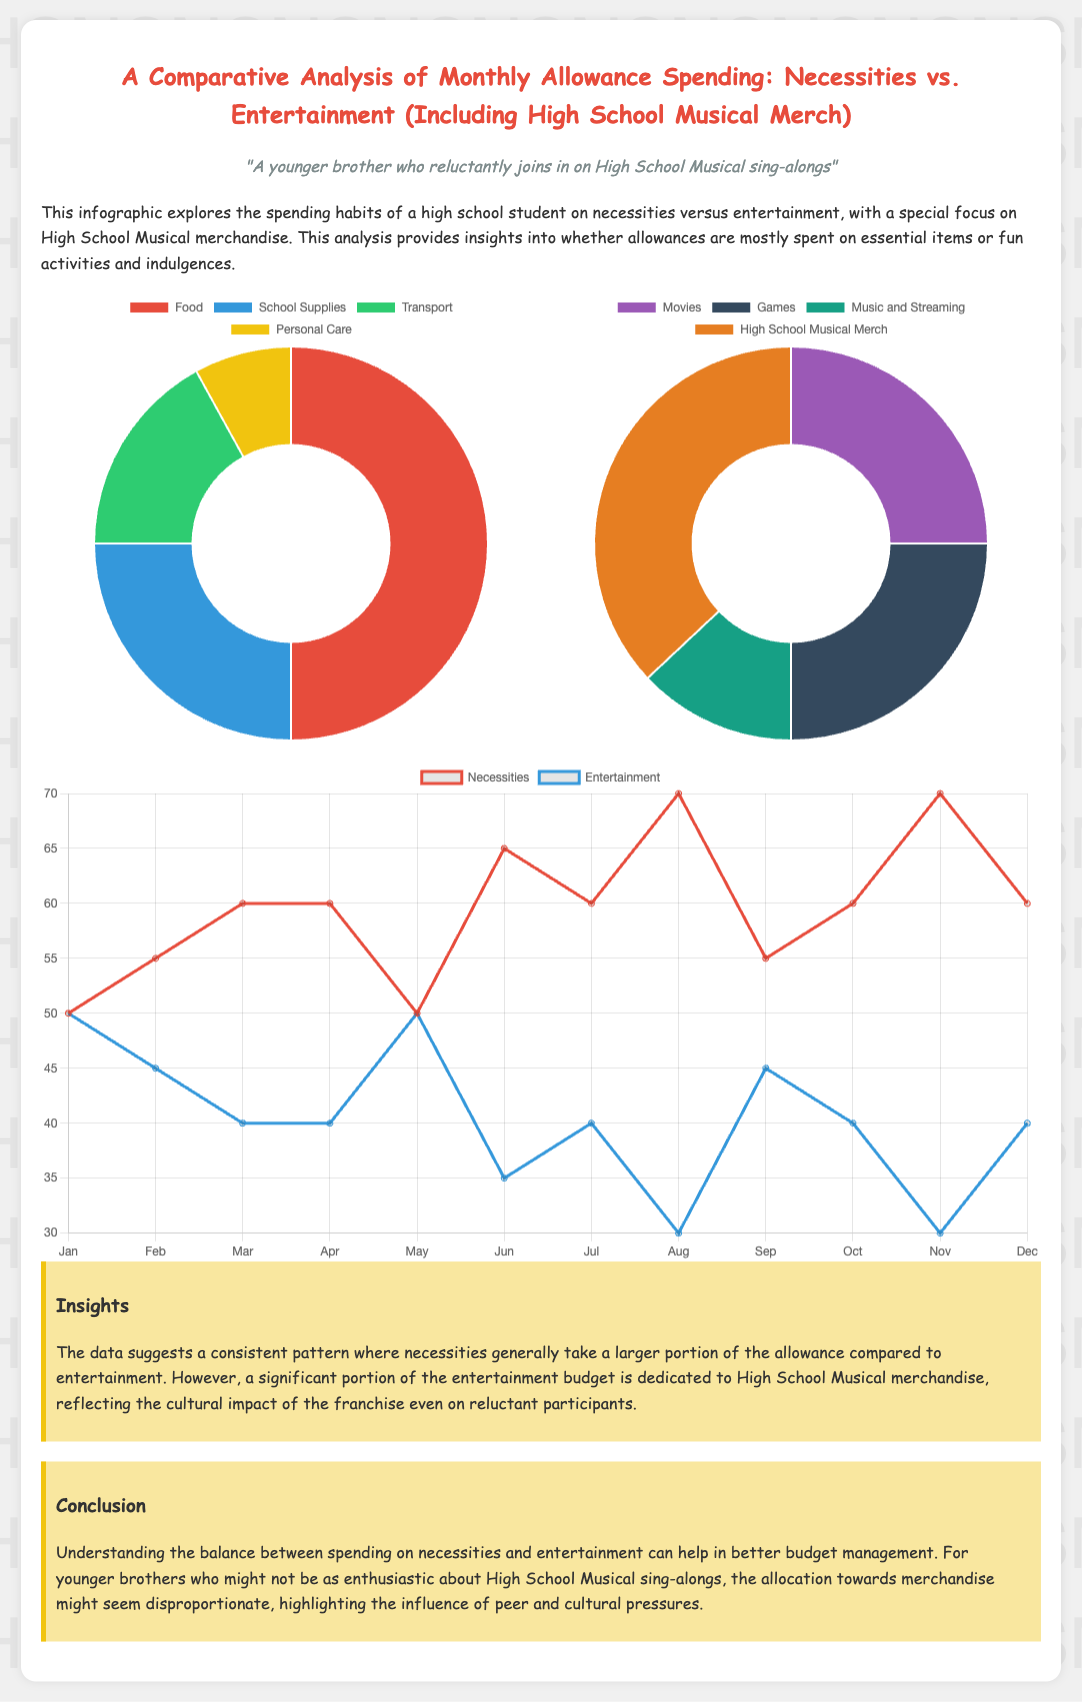What is the title of the document? The title of the document summarizes the subject of the analysis, focusing on monthly allowance spending compared to necessities and entertainment.
Answer: A Comparative Analysis of Monthly Allowance Spending: Necessities vs. Entertainment (Including High School Musical Merch) What percentage of the allowance is spent on food? The infographic provides a breakdown of necessities spending, indicating the proportion dedicated to food.
Answer: 50 How much is allocated to High School Musical merchandise? The entertainment chart details the spending distribution, highlighting the amount spent on High School Musical merchandise.
Answer: 37 In which month does the entertainment spending peak? The line graph shows the trend of entertainment spending throughout the year, identifying the month with the highest spending.
Answer: April Which category has a larger budget share, necessities or entertainment? A comparison of the total amount spent on necessities versus entertainment shows which category dominates the spending behavior.
Answer: Necessities What is the total percentage of the allowance spent on personal care? The necessities chart indicates the specific allocation for personal care within total spending on necessities.
Answer: 8 What was the spending trend for entertainment in June? The line chart shows the entertainment spending for the month of June in the yearly breakdown.
Answer: 35 Which color represents Transport in the necessities chart? The color coding of the doughnut chart allows us to identify which color corresponds to the Transport category.
Answer: Blue What does the infographic suggest about the influence of cultural pressures? The conclusion discusses the impact of cultural factors on spending behavior, particularly regarding merchandise.
Answer: Disproportionate 